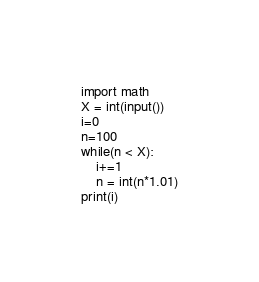<code> <loc_0><loc_0><loc_500><loc_500><_Python_>import math
X = int(input())
i=0
n=100
while(n < X):
    i+=1
    n = int(n*1.01)
print(i)</code> 